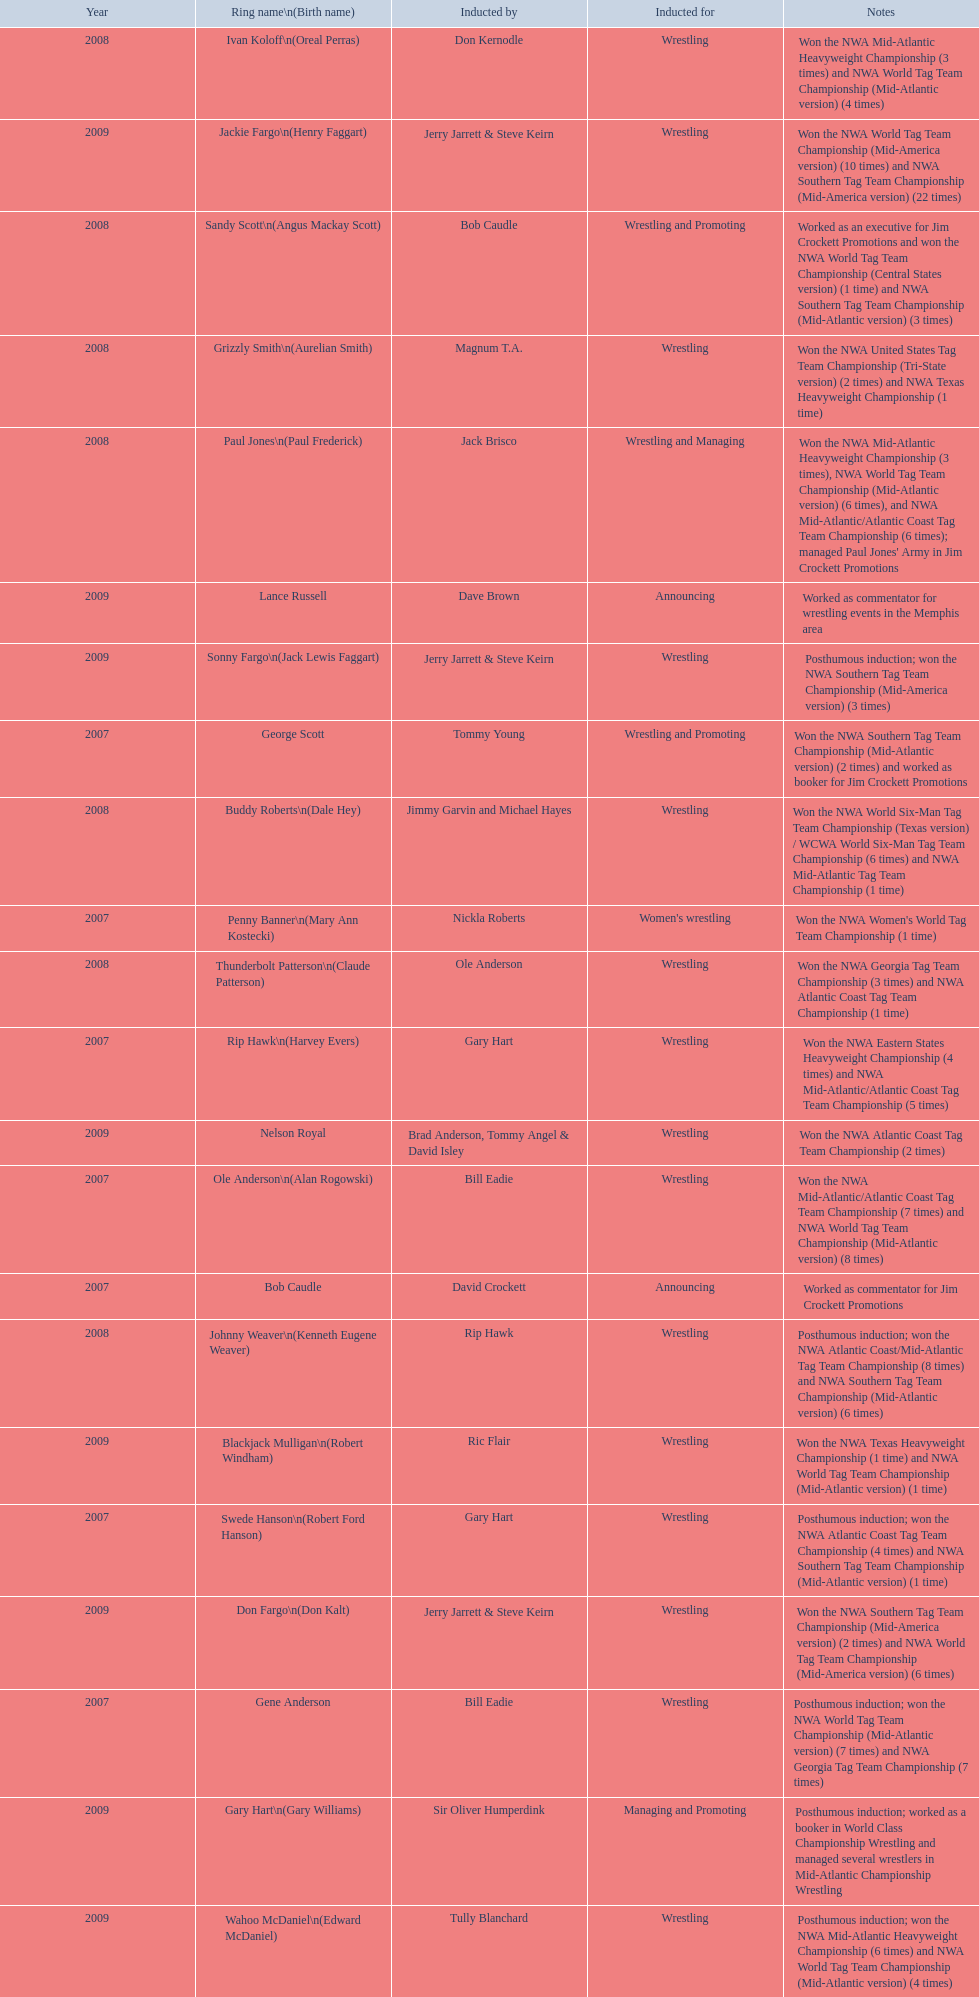What announcers were inducted? Bob Caudle, Lance Russell. What announcer was inducted in 2009? Lance Russell. 